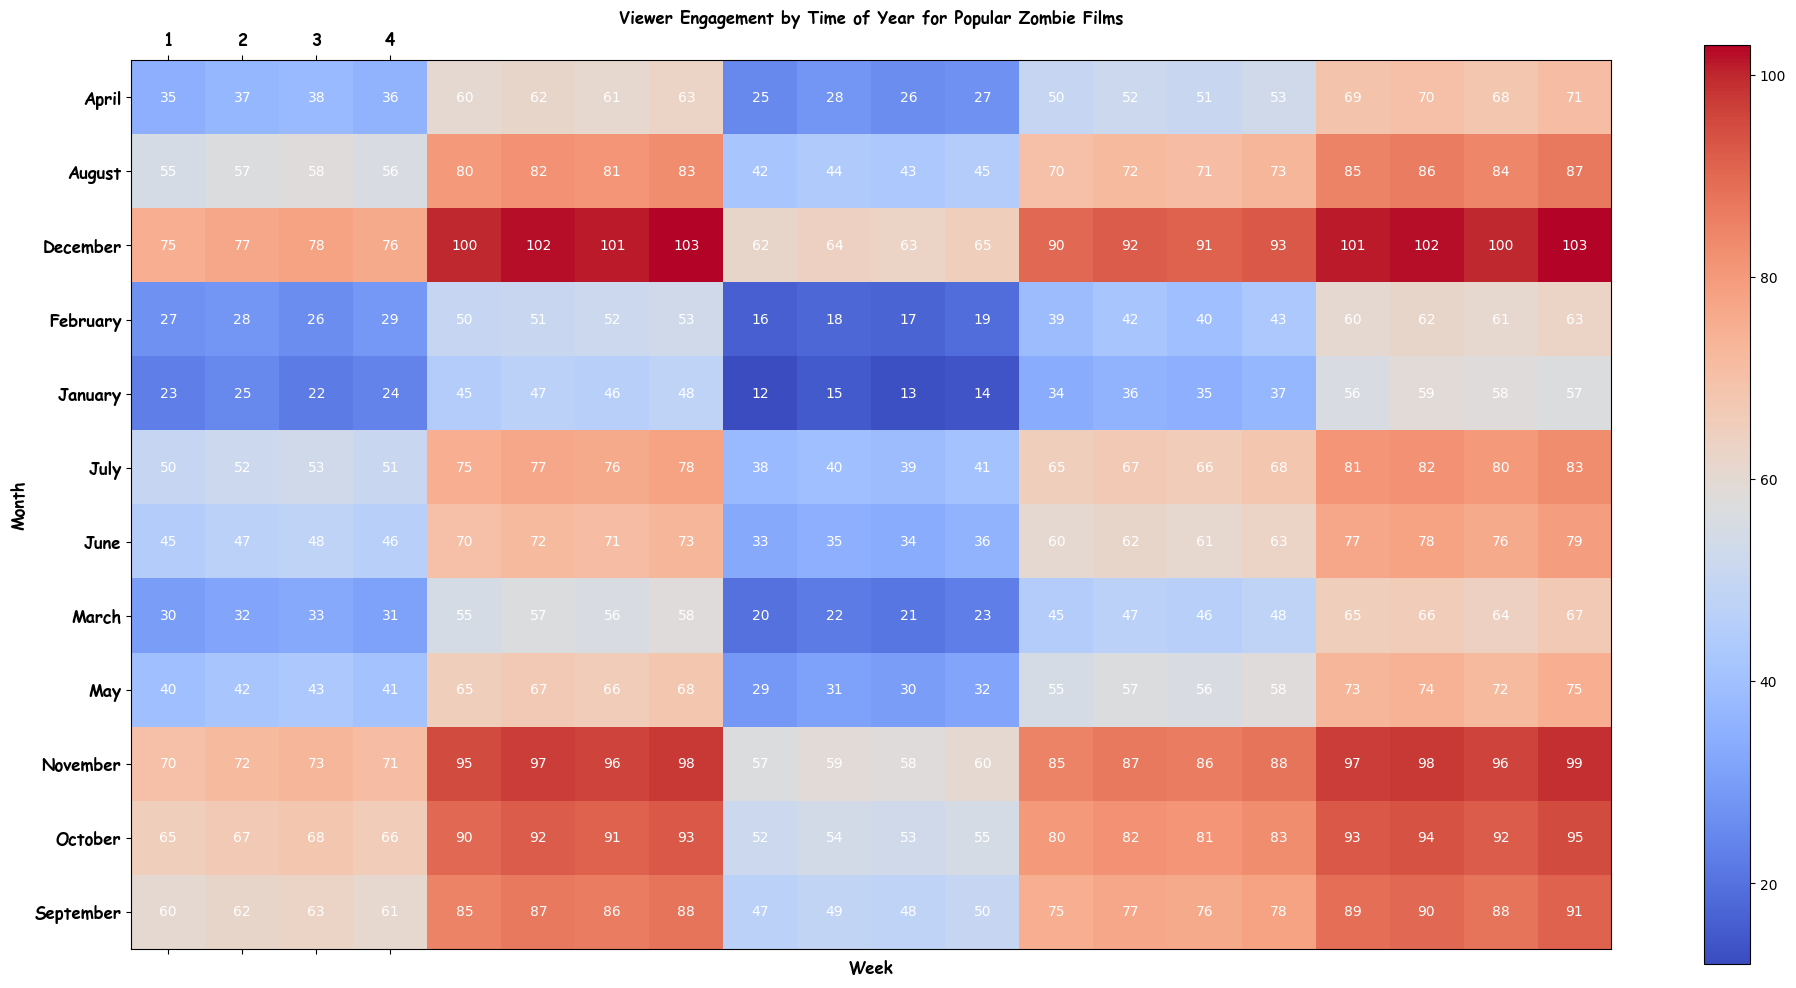What's the overall trend of viewer engagement from January to December for all zombie films? By observing the heatmap, viewer engagement trends upward from January to December for all films, indicating increasing popularity or interest as the year progresses.
Answer: Upward trend Which zombie film had the highest viewer engagement in the first week of July? The first week of July corresponds to the top row of July in the heatmap. The highest number in this row is 81, which belongs to Zombie Film 5.
Answer: Zombie Film 5 In which month did Zombie Film 3 show the highest viewer engagement, and what was the value? Locate the column for Zombie Film 3 and identify the highest value. The highest value is in December (Week 4), which is 65.
Answer: December, 65 What is the average viewer engagement in March for Zombie Film 2? Zombie Film 2 in March has values 55, 57, 56, and 58. The average is calculated as (55 + 57 + 56 + 58) / 4 = 226 / 4 = 56.5.
Answer: 56.5 Compare viewer engagement of Zombie Film 4 and Zombie Film 5 in September. Which one has higher engagement overall, and by how much? Sum the viewer engagements for September weeks for both films: Zombie Film 4: (75+77+76+78) = 306; Zombie Film 5: (89+90+88+91) = 358. Difference is 358 - 306 = 52.
Answer: Zombie Film 5, 52 Which month shows the most significant increase in viewer engagement for Zombie Film 1 compared to the previous month? Calculate the difference in engagement between each month for Zombie Film 1. The month with the highest increment is October, with an increase from 63 in September to 65 in October (2-point increase).
Answer: October What's the maximum viewer engagement value across all films and months, and where does it occur? Identify the highest value in the heatmap, which is 103, and it occurs in December (Week 4) for Zombie Films 2 and 5.
Answer: 103, December What is the total viewer engagement for Zombie Film 1 in the last quarter of the year (October, November, December)? Sum the values for October, November, and December for Zombie Film 1: (65+67+68+66) + (70+72+73+71) + (75+77+78+76) = 360.
Answer: 360 